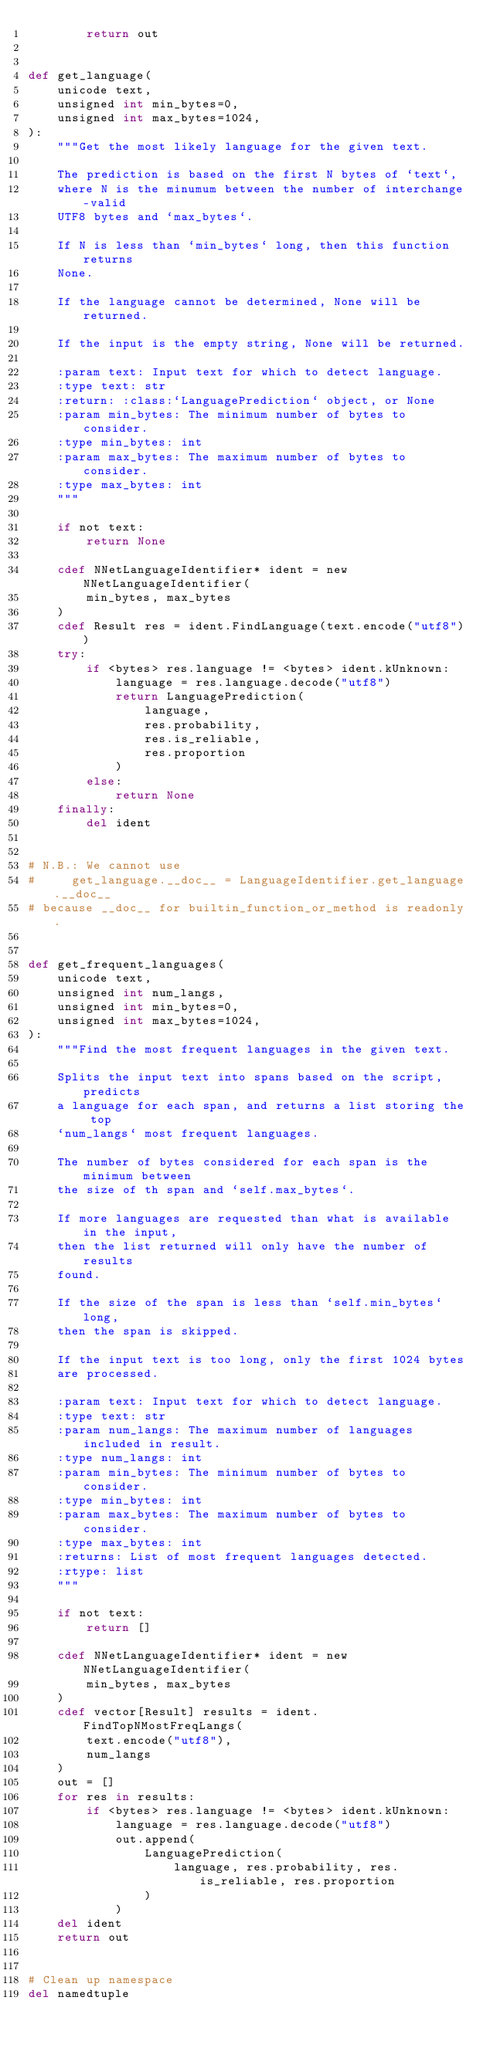<code> <loc_0><loc_0><loc_500><loc_500><_Cython_>        return out


def get_language(
    unicode text,
    unsigned int min_bytes=0,
    unsigned int max_bytes=1024,
):
    """Get the most likely language for the given text.

    The prediction is based on the first N bytes of `text`,
    where N is the minumum between the number of interchange-valid
    UTF8 bytes and `max_bytes`.

    If N is less than `min_bytes` long, then this function returns
    None.

    If the language cannot be determined, None will be returned.

    If the input is the empty string, None will be returned.

    :param text: Input text for which to detect language.
    :type text: str
    :return: :class:`LanguagePrediction` object, or None
    :param min_bytes: The minimum number of bytes to consider.
    :type min_bytes: int
    :param max_bytes: The maximum number of bytes to consider.
    :type max_bytes: int
    """

    if not text:
        return None

    cdef NNetLanguageIdentifier* ident = new NNetLanguageIdentifier(
        min_bytes, max_bytes
    )
    cdef Result res = ident.FindLanguage(text.encode("utf8"))
    try:
        if <bytes> res.language != <bytes> ident.kUnknown:
            language = res.language.decode("utf8")
            return LanguagePrediction(
                language,
                res.probability,
                res.is_reliable,
                res.proportion
            )
        else:
            return None
    finally:
        del ident


# N.B.: We cannot use
#     get_language.__doc__ = LanguageIdentifier.get_language.__doc__
# because __doc__ for builtin_function_or_method is readonly.


def get_frequent_languages(
    unicode text,
    unsigned int num_langs,
    unsigned int min_bytes=0,
    unsigned int max_bytes=1024,
):
    """Find the most frequent languages in the given text.

    Splits the input text into spans based on the script, predicts
    a language for each span, and returns a list storing the top
    `num_langs` most frequent languages.

    The number of bytes considered for each span is the minimum between
    the size of th span and `self.max_bytes`.

    If more languages are requested than what is available in the input,
    then the list returned will only have the number of results
    found.

    If the size of the span is less than `self.min_bytes` long,
    then the span is skipped.

    If the input text is too long, only the first 1024 bytes
    are processed.

    :param text: Input text for which to detect language.
    :type text: str
    :param num_langs: The maximum number of languages included in result.
    :type num_langs: int
    :param min_bytes: The minimum number of bytes to consider.
    :type min_bytes: int
    :param max_bytes: The maximum number of bytes to consider.
    :type max_bytes: int
    :returns: List of most frequent languages detected.
    :rtype: list
    """

    if not text:
        return []

    cdef NNetLanguageIdentifier* ident = new NNetLanguageIdentifier(
        min_bytes, max_bytes
    )
    cdef vector[Result] results = ident.FindTopNMostFreqLangs(
        text.encode("utf8"),
        num_langs
    )
    out = []
    for res in results:
        if <bytes> res.language != <bytes> ident.kUnknown:
            language = res.language.decode("utf8")
            out.append(
                LanguagePrediction(
                    language, res.probability, res.is_reliable, res.proportion
                )
            )
    del ident
    return out


# Clean up namespace
del namedtuple
</code> 